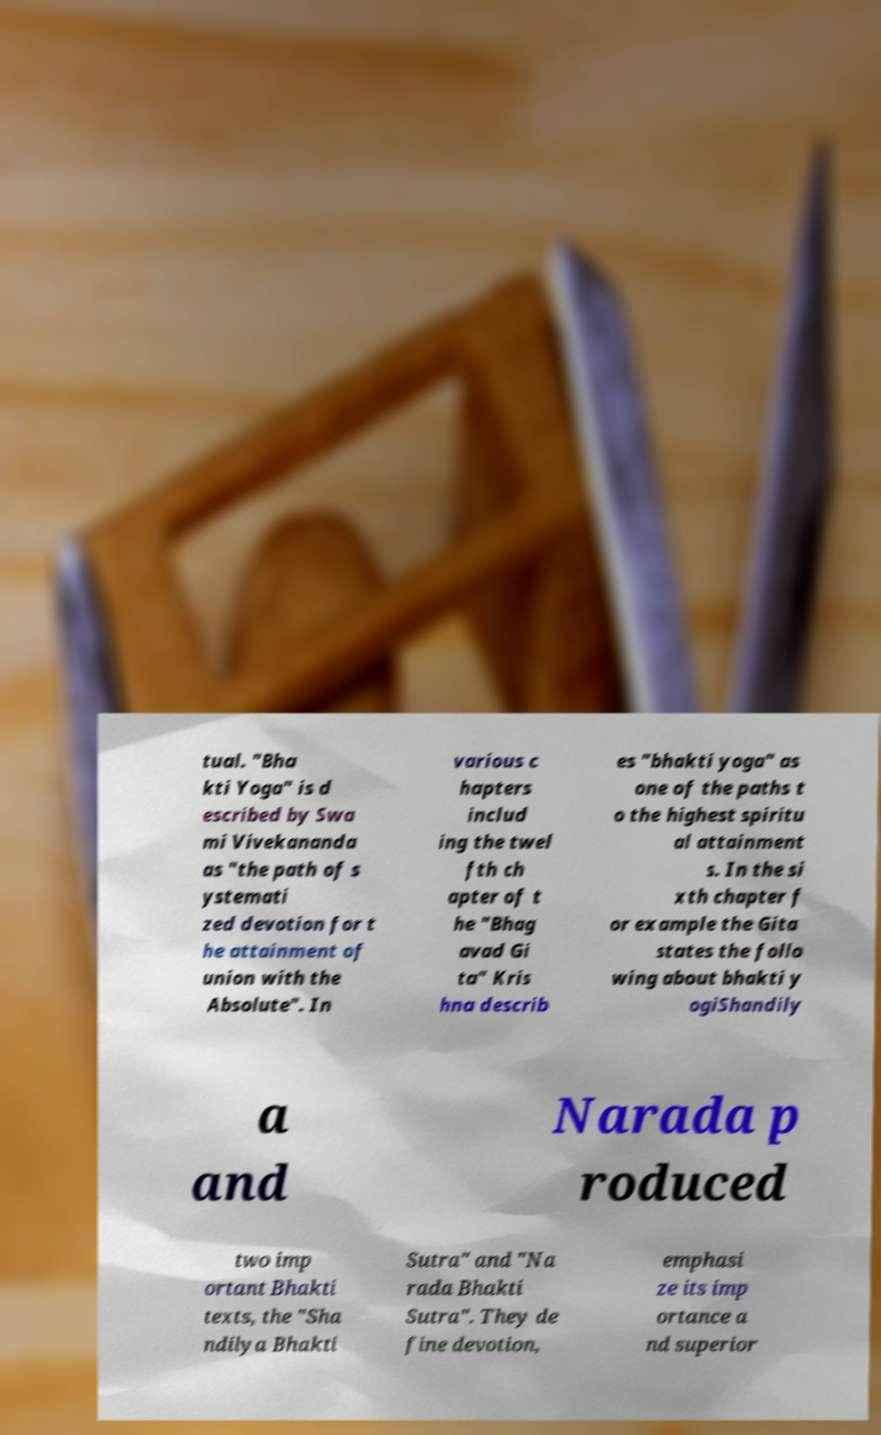There's text embedded in this image that I need extracted. Can you transcribe it verbatim? tual. "Bha kti Yoga" is d escribed by Swa mi Vivekananda as "the path of s ystemati zed devotion for t he attainment of union with the Absolute". In various c hapters includ ing the twel fth ch apter of t he "Bhag avad Gi ta" Kris hna describ es "bhakti yoga" as one of the paths t o the highest spiritu al attainment s. In the si xth chapter f or example the Gita states the follo wing about bhakti y ogiShandily a and Narada p roduced two imp ortant Bhakti texts, the "Sha ndilya Bhakti Sutra" and "Na rada Bhakti Sutra". They de fine devotion, emphasi ze its imp ortance a nd superior 